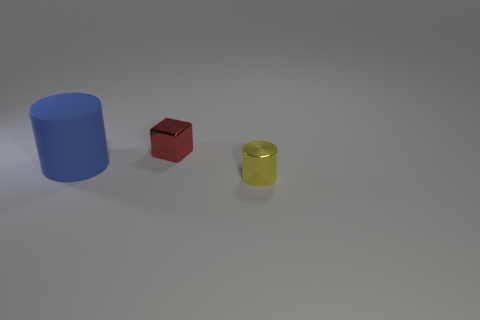Add 2 cylinders. How many objects exist? 5 Subtract 1 cubes. How many cubes are left? 0 Subtract all red blocks. How many cyan cylinders are left? 0 Subtract all small matte spheres. Subtract all rubber cylinders. How many objects are left? 2 Add 3 tiny red things. How many tiny red things are left? 4 Add 2 yellow metallic cylinders. How many yellow metallic cylinders exist? 3 Subtract 0 blue spheres. How many objects are left? 3 Subtract all cylinders. How many objects are left? 1 Subtract all purple cylinders. Subtract all green cubes. How many cylinders are left? 2 